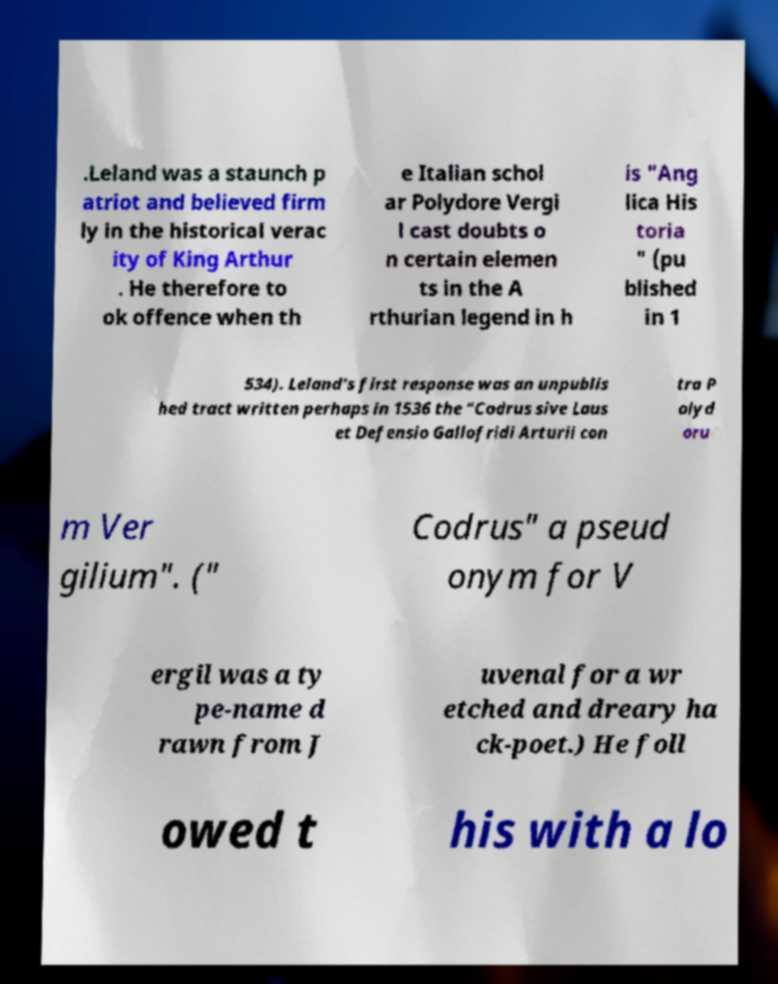Could you extract and type out the text from this image? .Leland was a staunch p atriot and believed firm ly in the historical verac ity of King Arthur . He therefore to ok offence when th e Italian schol ar Polydore Vergi l cast doubts o n certain elemen ts in the A rthurian legend in h is "Ang lica His toria " (pu blished in 1 534). Leland's first response was an unpublis hed tract written perhaps in 1536 the "Codrus sive Laus et Defensio Gallofridi Arturii con tra P olyd oru m Ver gilium". (" Codrus" a pseud onym for V ergil was a ty pe-name d rawn from J uvenal for a wr etched and dreary ha ck-poet.) He foll owed t his with a lo 